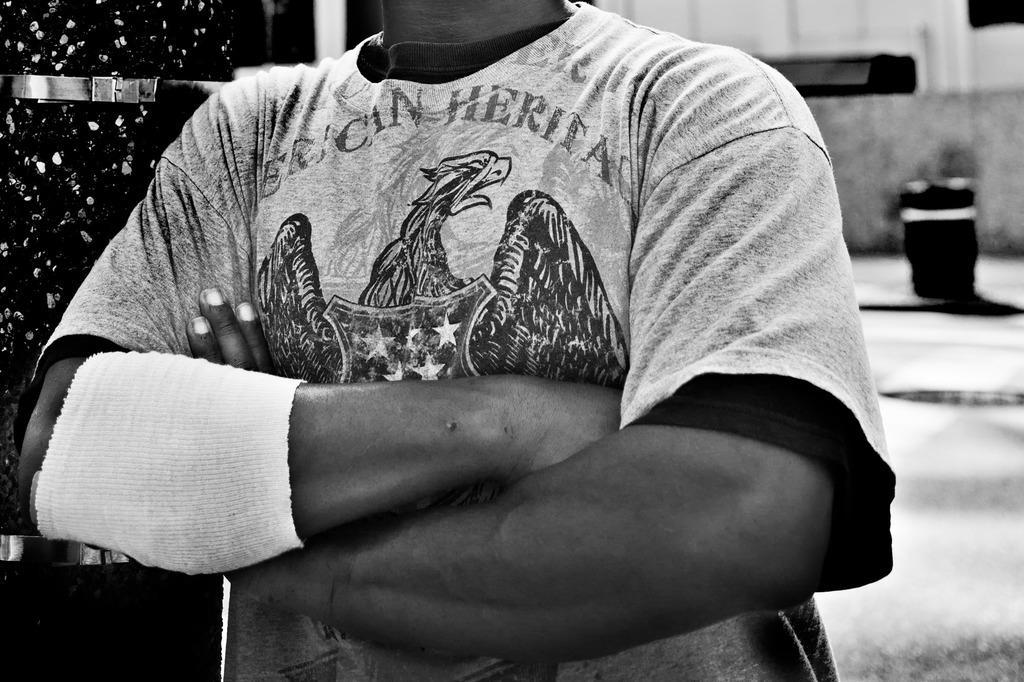In one or two sentences, can you explain what this image depicts? This is the black and white image where we can see a person wearing T-shirt on which we can see a bird and we can see a band on the hand. The background of the image is slightly blurred. 